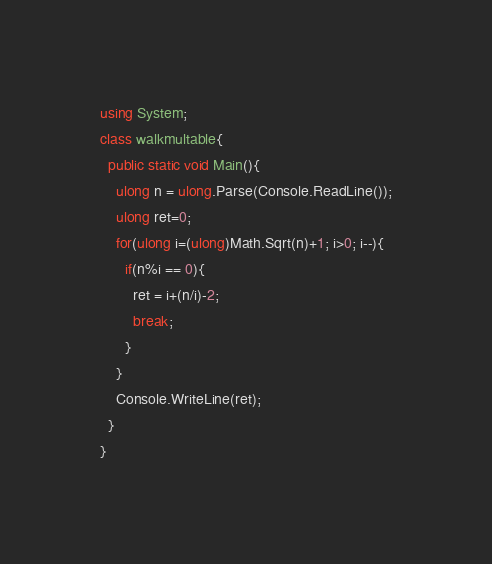<code> <loc_0><loc_0><loc_500><loc_500><_C#_>using System;
class walkmultable{
  public static void Main(){
    ulong n = ulong.Parse(Console.ReadLine());
    ulong ret=0;
    for(ulong i=(ulong)Math.Sqrt(n)+1; i>0; i--){
      if(n%i == 0){
        ret = i+(n/i)-2;
        break;
      }
    }
    Console.WriteLine(ret);
  }
}
</code> 